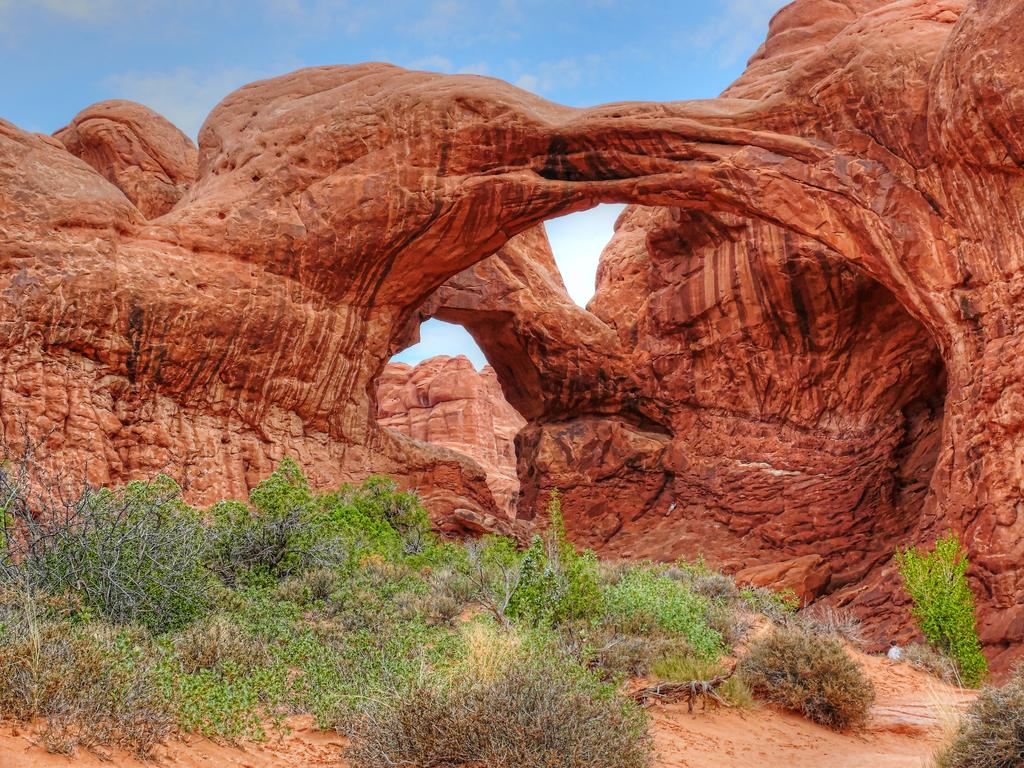What is the main feature in the center of the image? There are mountains in the center of the image. What type of terrain is visible at the bottom of the image? There is grass and sand at the bottom of the image. What is visible at the top of the image? The sky is visible at the top of the image. What is the weight of the pet that can be heard barking in the image? There is no pet present in the image, and no barking can be heard. 